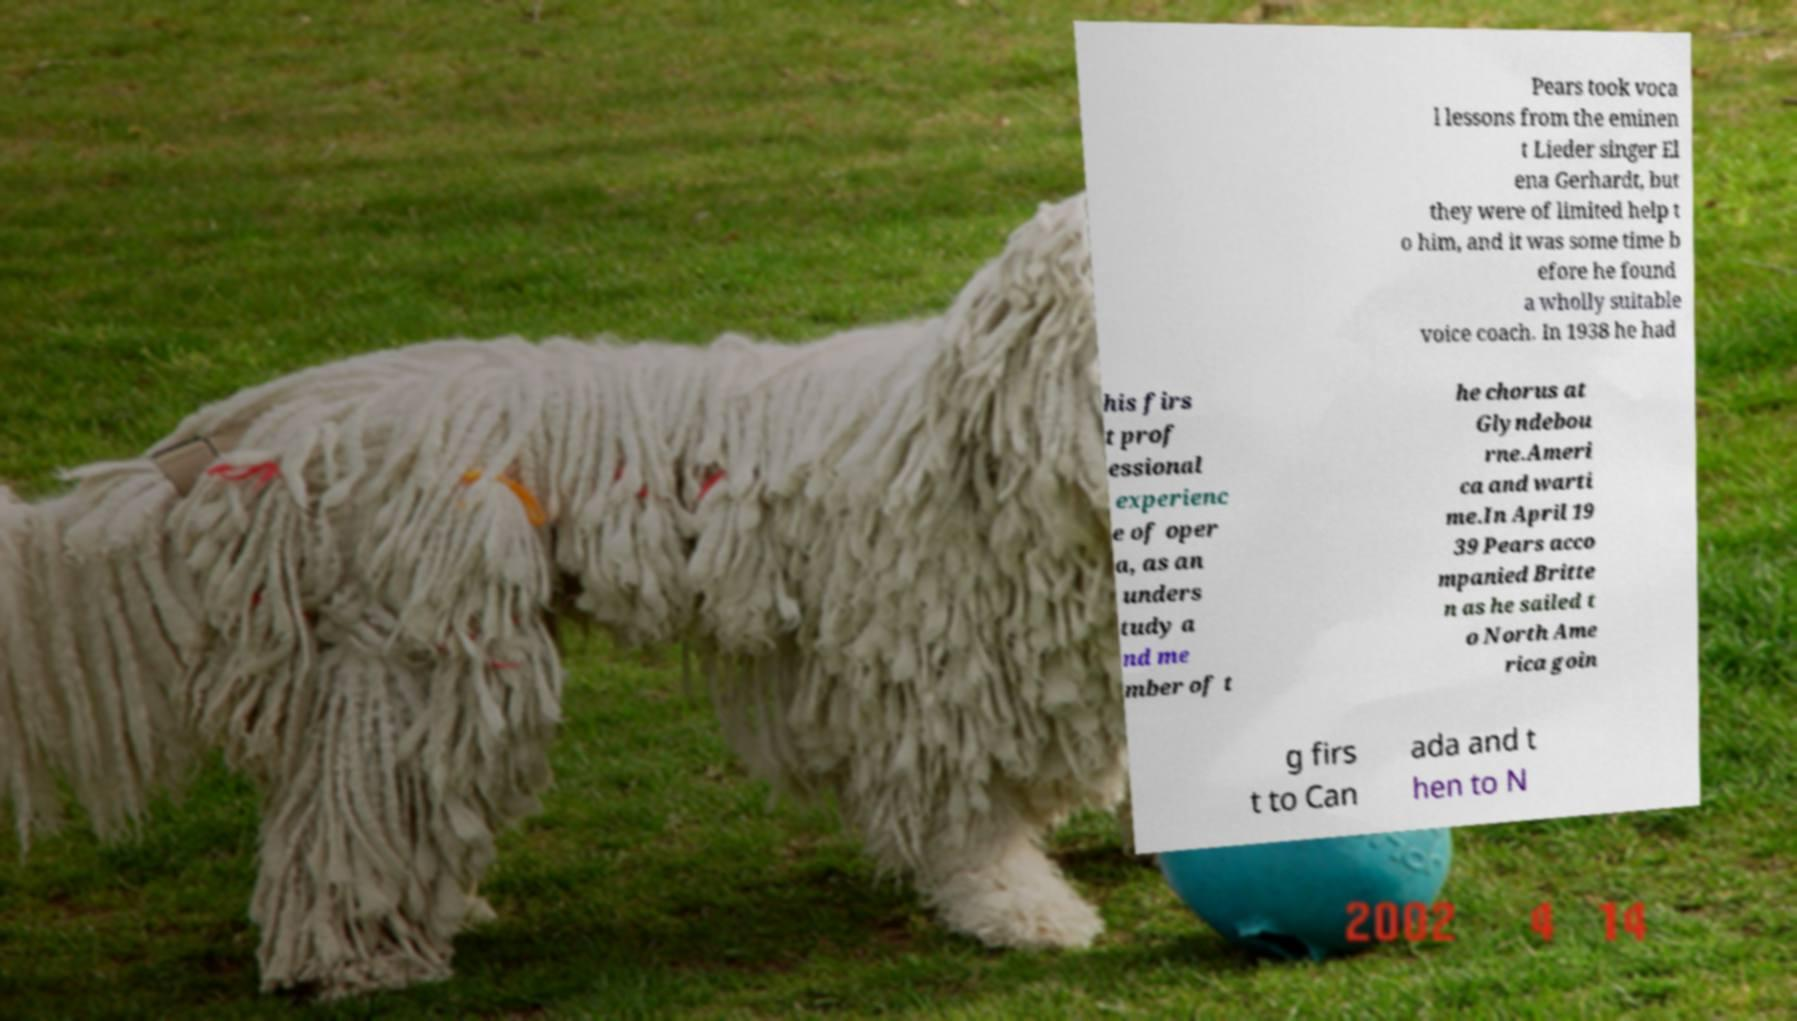Can you read and provide the text displayed in the image?This photo seems to have some interesting text. Can you extract and type it out for me? Pears took voca l lessons from the eminen t Lieder singer El ena Gerhardt, but they were of limited help t o him, and it was some time b efore he found a wholly suitable voice coach. In 1938 he had his firs t prof essional experienc e of oper a, as an unders tudy a nd me mber of t he chorus at Glyndebou rne.Ameri ca and warti me.In April 19 39 Pears acco mpanied Britte n as he sailed t o North Ame rica goin g firs t to Can ada and t hen to N 